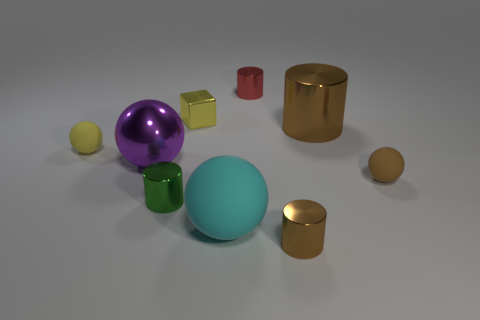Subtract all spheres. How many objects are left? 5 Add 8 yellow objects. How many yellow objects are left? 10 Add 3 small yellow matte objects. How many small yellow matte objects exist? 4 Subtract 0 purple blocks. How many objects are left? 9 Subtract all small brown matte objects. Subtract all tiny green metallic things. How many objects are left? 7 